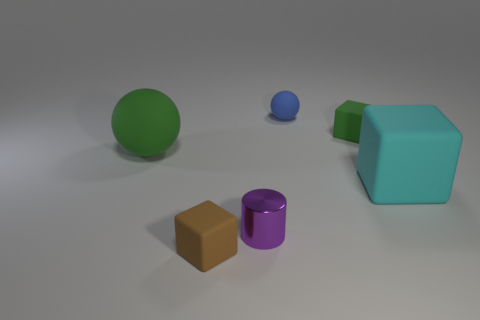Subtract all tiny blocks. How many blocks are left? 1 Subtract all brown cubes. How many cubes are left? 2 Add 2 big yellow rubber balls. How many objects exist? 8 Subtract all cylinders. How many objects are left? 5 Subtract all brown spheres. How many green cubes are left? 1 Add 5 blocks. How many blocks are left? 8 Add 3 tiny blue matte objects. How many tiny blue matte objects exist? 4 Subtract 0 gray cylinders. How many objects are left? 6 Subtract 2 blocks. How many blocks are left? 1 Subtract all cyan spheres. Subtract all brown blocks. How many spheres are left? 2 